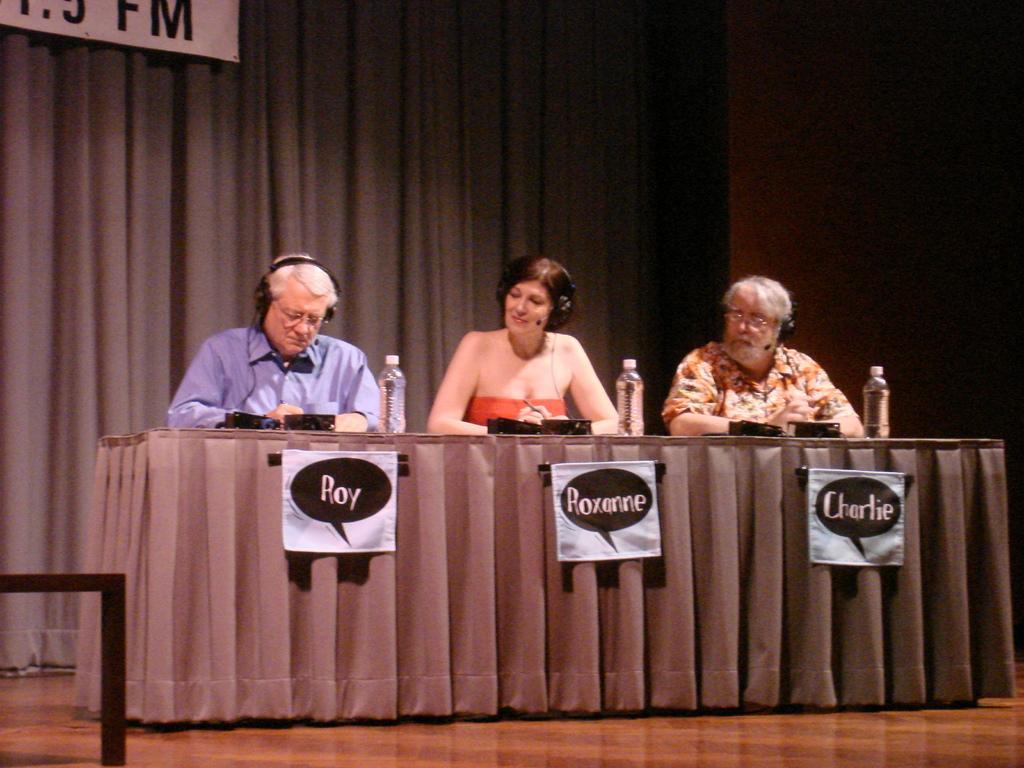Can you describe this image briefly? In this image I can see there are three persons visible in front of the table , on the table I can see a gray color cloth, on the cloth I can see three bottles at the top I can see a gray color curtain. 